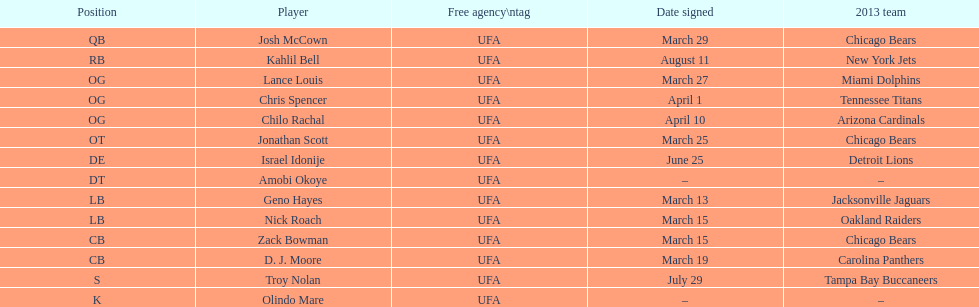Total count of players who registered in march? 7. 